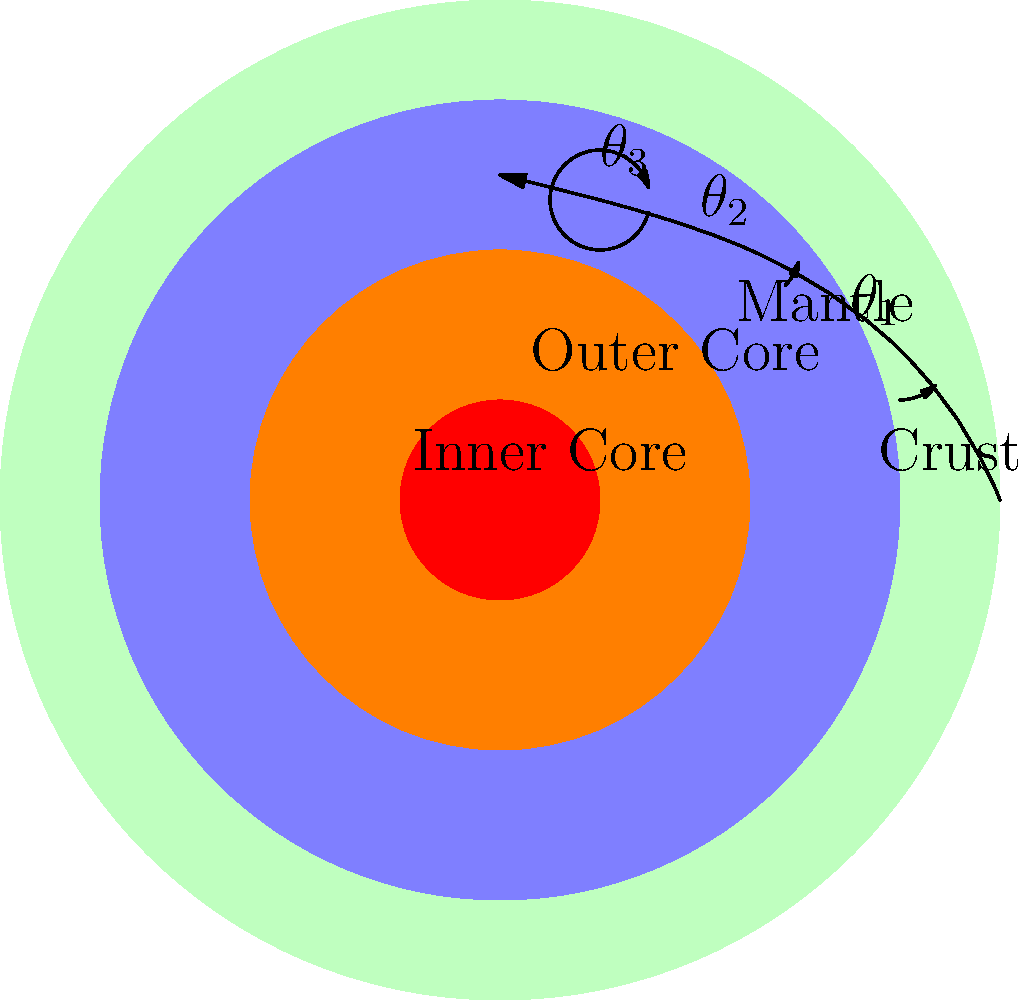A seismic wave is propagating through different layers of the Earth as shown in the diagram. If the angles of refraction at each interface are $\theta_1 = 45°$, $\theta_2 = 30°$, and $\theta_3 = 30°$, calculate the total angular deviation of the wave path from its original direction. Assume the wave enters the crust perpendicularly. To calculate the total angular deviation, we need to follow these steps:

1) First, understand that the total deviation is the sum of all changes in direction.

2) At the crust-mantle interface:
   - Incoming angle: 0° (perpendicular)
   - Outgoing angle: $\theta_1 = 45°$
   - Deviation: $45° - 0° = 45°$

3) At the mantle-outer core interface:
   - Incoming angle: $45°$
   - Outgoing angle: $\theta_2 = 30°$
   - Deviation: $45° - 30° = 15°$

4) At the outer core-inner core interface:
   - Incoming angle: $30°$
   - Outgoing angle: $\theta_3 = 30°$
   - Deviation: $30° - 30° = 0°$

5) Sum up all deviations:
   Total deviation = $45° + 15° + 0° = 60°$

Therefore, the total angular deviation of the wave path from its original direction is 60°.
Answer: $60°$ 